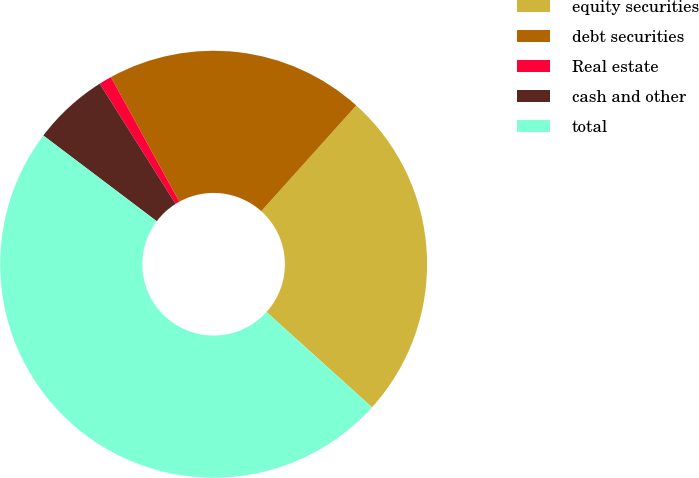<chart> <loc_0><loc_0><loc_500><loc_500><pie_chart><fcel>equity securities<fcel>debt securities<fcel>Real estate<fcel>cash and other<fcel>total<nl><fcel>25.04%<fcel>19.64%<fcel>0.97%<fcel>5.74%<fcel>48.61%<nl></chart> 